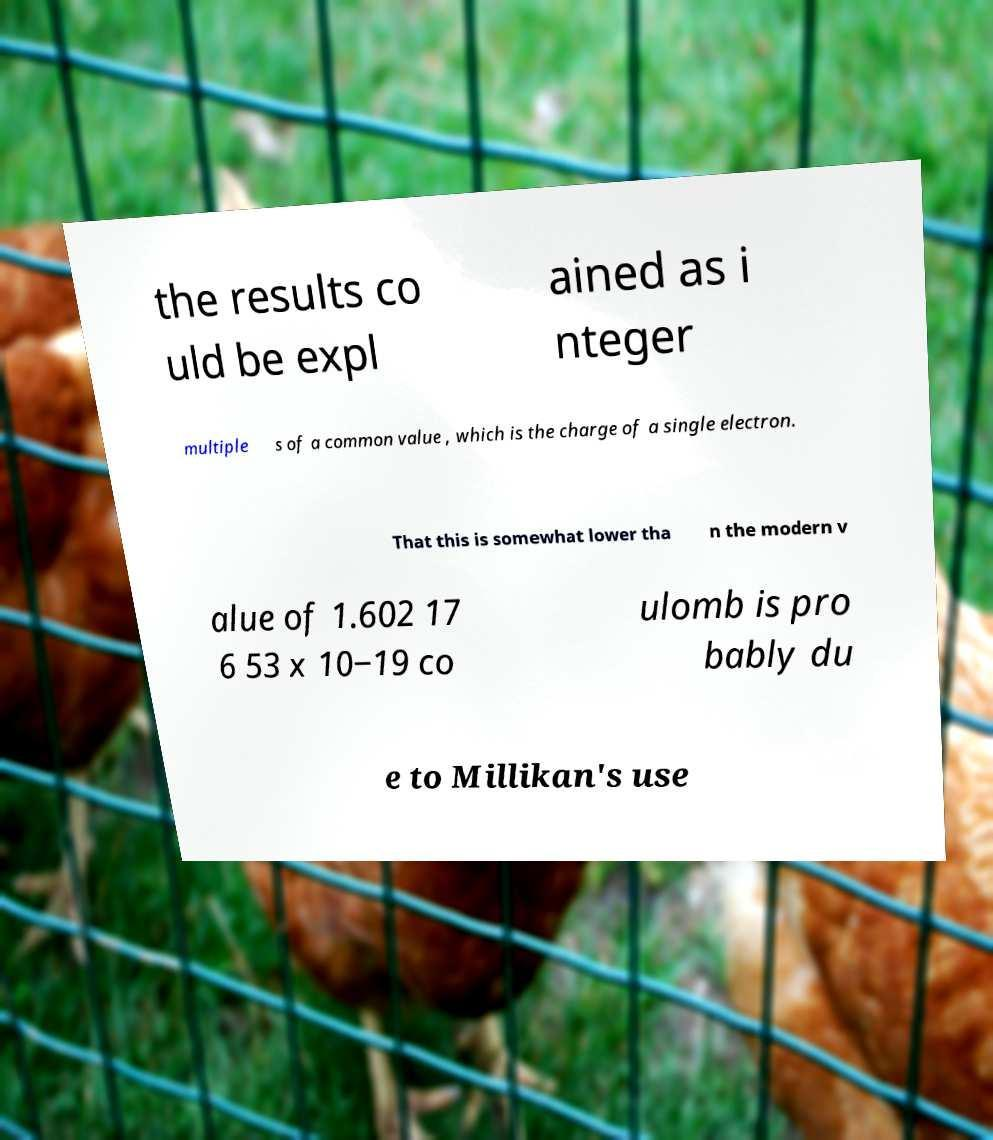Can you accurately transcribe the text from the provided image for me? the results co uld be expl ained as i nteger multiple s of a common value , which is the charge of a single electron. That this is somewhat lower tha n the modern v alue of 1.602 17 6 53 x 10−19 co ulomb is pro bably du e to Millikan's use 